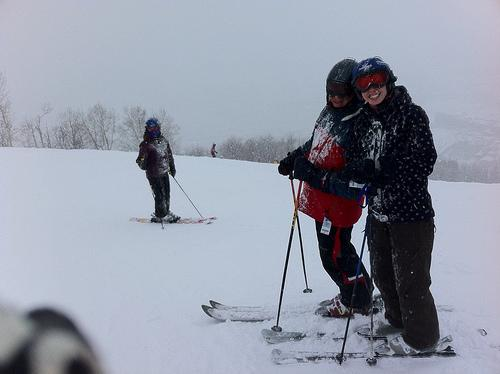What is the primary scene depicted in the image? A snowy mountain landscape with two people skiing, surrounded by bare trees and a grey sky. What kind of weather is depicted in the image? A cold, snowy winter day with a grey sky suggesting overcast or cloudy conditions. Quantify the number of main subjects present in the image. There are two main subjects, both people about to ski or skiing on the mountain. Identify any other significant elements around the main subject. There are white dots on a coat, a white ski lift pass, and the two people are wearing winter goggles and dark grey winter pants. Describe an ongoing activity related to the main subject. A woman is holding a pair of ski poles, preparing to ski or actively skiing down the mountain slope. Please provide a short summary of the image contents. The image features a snowy mountain scene with two people skiing, surrounded by bare trees and a grey sky. Details include white dots on a coat, ski lift pass, winter goggles, and dark grey pants. What is the overall mood or sentiment present in the image? The mood in the image is active and adventurous, as the people are engaging in a winter sport amidst a snowy landscape. What can be inferred about the location of the image based on the given information? The image is set on a mountain covered with thick snow, suggesting a location at a ski resort or a winter sports area. Can you describe the object interaction happening in the image? The two people are standing beside each other on skis, possibly getting ready to ski or taking a break, while a woman holds a pair of ski poles. How many white dots on the coat are visible in the image, and what do they look like? There are 10 white dots on the coat, and they appear as small, distinct, round or elliptical shapes. 